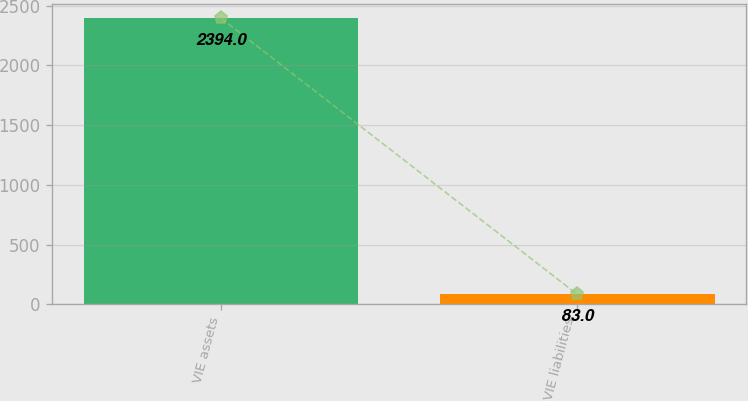Convert chart. <chart><loc_0><loc_0><loc_500><loc_500><bar_chart><fcel>VIE assets<fcel>VIE liabilities<nl><fcel>2394<fcel>83<nl></chart> 